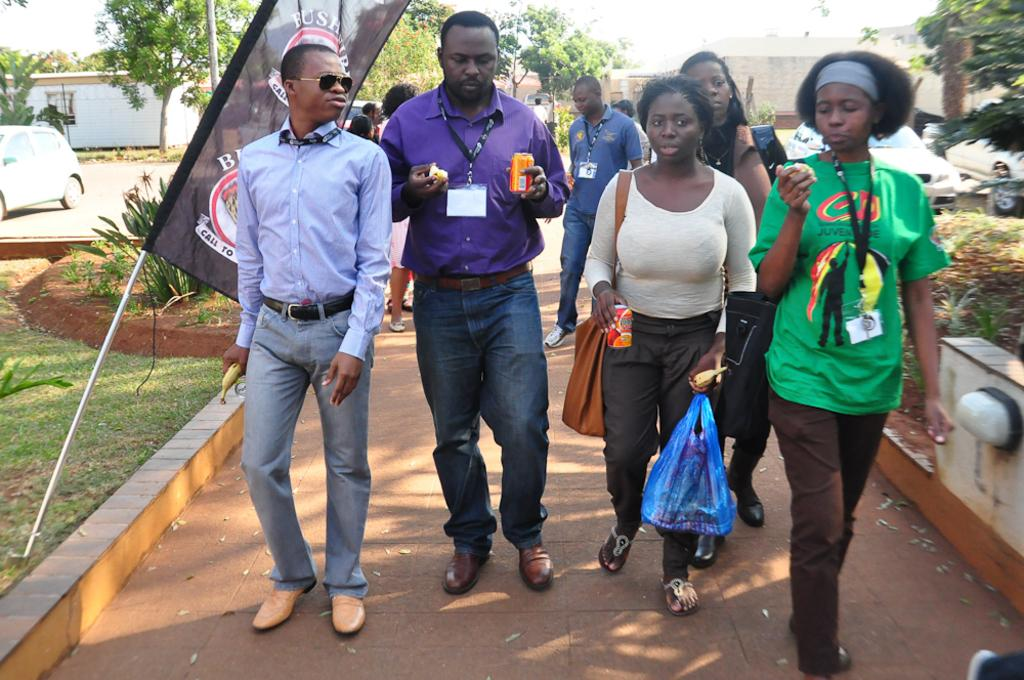What are the people in the image doing? The people in the image are walking on the ground. What are the people holding in the image? The people are holding objects. What can be seen parked on the ground in the image? There are vehicles parked on the ground in the image. What type of vegetation is present in the image? There are trees and grass in the image. What is the flag attached to in the image? The flag is attached to a pole or structure in the image. What is the wall made of in the image? The wall is likely made of brick, stone, or concrete in the image. What is visible in the sky in the image? The sky is visible in the image, but no specific details about the sky are mentioned in the facts. Where is the throne located in the image? There is no throne present in the image. What type of throat condition can be seen in the image? There is no mention of any throat conditions or issues in the image. 